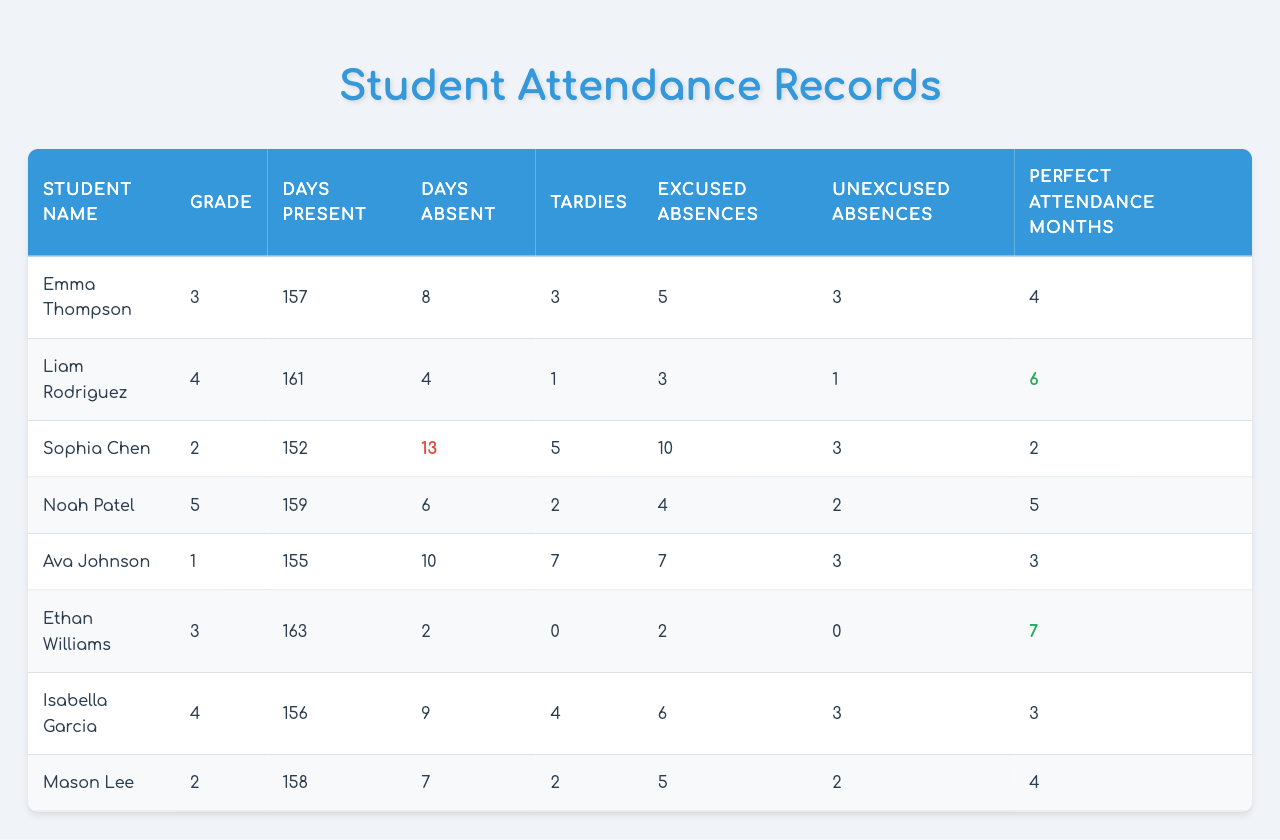What is the name of the student with the most perfect attendance months? Looking at the table, Ethan Williams has 7 perfect attendance months, which is the highest among all students.
Answer: Ethan Williams How many days was Sophia Chen absent? The table indicates that Sophia Chen was absent for 13 days this school year.
Answer: 13 days What is the average number of days present for all students? The total number of days present for all students is 157 + 161 + 152 + 159 + 155 + 163 + 156 + 158 = 1,161 days. There are 8 students, so the average is 1,161 / 8 = 145.125 days.
Answer: 145.125 days Which student had the least number of tardies? By comparing the tardies for each student, Ethan Williams has 0 tardies, which is the least.
Answer: Ethan Williams Is there any student with perfect attendance months equal to or greater than 6? Yes, Ethan Williams (7 months) and Liam Rodriguez (6 months) have perfect attendance months equal to or greater than 6.
Answer: Yes What is the total number of excused absences among all students? Summing all excused absences: 5 + 3 + 10 + 4 + 7 + 2 + 6 + 5 = 42.
Answer: 42 Which student has the highest number of days absent? Sophia Chen has the highest number of days absent, totaling 13 days.
Answer: Sophia Chen How many students were tardy more than 5 times? Mason Lee (7) and Sophia Chen (5) were tardy more than 5 times. Only Sophia Chen fits this category with exactly 5, so the answer is one student.
Answer: One student What is the difference in days present between Ava Johnson and Noah Patel? Ava Johnson was present for 155 days while Noah Patel was present for 159 days. The difference is 159 - 155 = 4 days.
Answer: 4 days Can you summarize the total number of unexcused absences? The total number of unexcused absences is calculated as: 3 + 1 + 3 + 2 + 3 + 0 + 3 + 2 = 17.
Answer: 17 